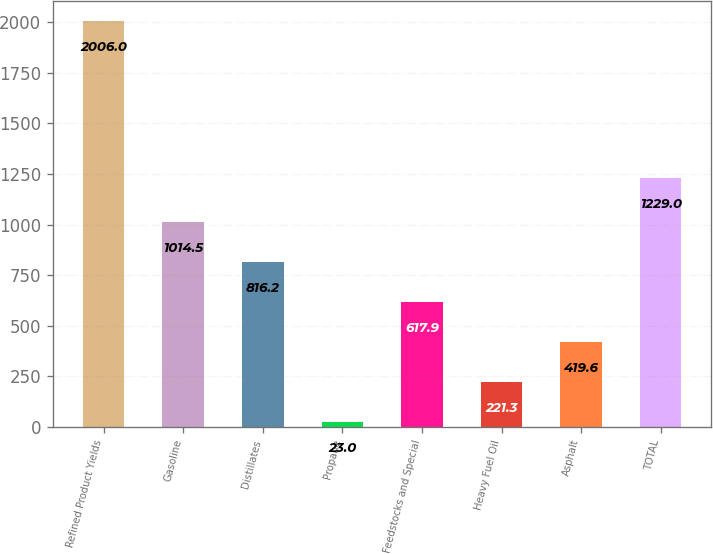Convert chart. <chart><loc_0><loc_0><loc_500><loc_500><bar_chart><fcel>Refined Product Yields<fcel>Gasoline<fcel>Distillates<fcel>Propane<fcel>Feedstocks and Special<fcel>Heavy Fuel Oil<fcel>Asphalt<fcel>TOTAL<nl><fcel>2006<fcel>1014.5<fcel>816.2<fcel>23<fcel>617.9<fcel>221.3<fcel>419.6<fcel>1229<nl></chart> 